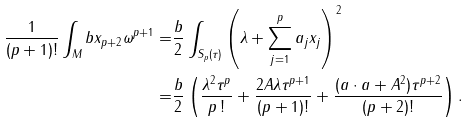<formula> <loc_0><loc_0><loc_500><loc_500>\frac { 1 } { ( p + 1 ) ! } \int _ { M } b x _ { p + 2 } \omega ^ { p + 1 } = & \frac { b } { 2 } \int _ { S _ { p } ( \tau ) } \left ( \lambda + \sum _ { j = 1 } ^ { p } a _ { j } x _ { j } \right ) ^ { 2 } \\ = & \frac { b } { 2 } \left ( \frac { \lambda ^ { 2 } \tau ^ { p } } { p \, ! } + \frac { 2 A \lambda \tau ^ { p + 1 } } { ( p + 1 ) ! } + \frac { ( { a } \cdot { a } + A ^ { 2 } ) \tau ^ { p + 2 } } { ( p + 2 ) ! } \right ) .</formula> 